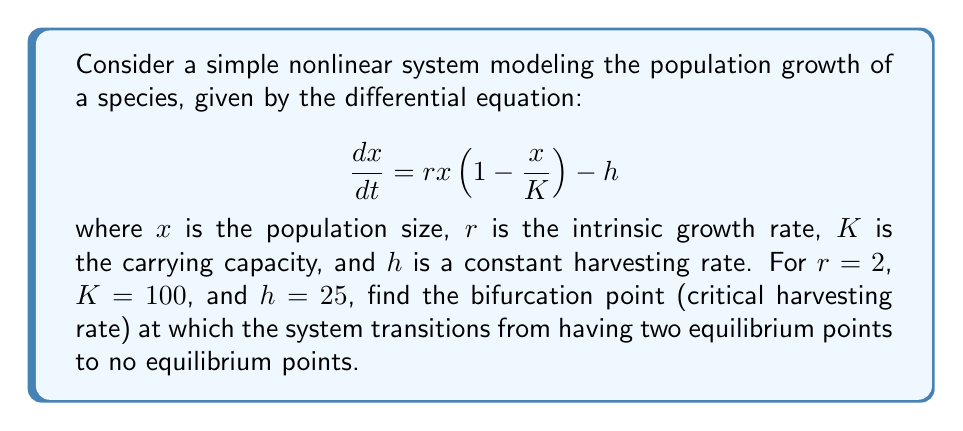Solve this math problem. Let's approach this step-by-step:

1) First, we need to find the equilibrium points. These occur when $\frac{dx}{dt} = 0$:

   $$0 = rx(1-\frac{x}{K}) - h$$

2) Substituting the given values and rearranging:

   $$0 = 2x(1-\frac{x}{100}) - 25$$
   $$0 = 2x - \frac{2x^2}{100} - 25$$
   $$0 = 2x - 0.02x^2 - 25$$

3) Multiplying everything by 50 to eliminate fractions:

   $$0 = 100x - x^2 - 1250$$

4) This is a quadratic equation. The system will have two equilibrium points when this equation has two real roots, one equilibrium point when it has one real root (at the bifurcation point), and no equilibrium points when it has no real roots.

5) For a quadratic equation $ax^2 + bx + c = 0$, the discriminant is given by $b^2 - 4ac$. At the bifurcation point, the discriminant equals zero.

6) In our case, $a=-1$, $b=100$, and $c=-1250$. The discriminant is:

   $$100^2 - 4(-1)(-1250) = 10000 - 5000 = 5000$$

7) This is positive, indicating two equilibrium points. We need to find the value of $h$ that makes the discriminant zero.

8) Let's rewrite our original equation with $h$ as a variable:

   $$0 = 2x - 0.02x^2 - h$$
   $$0 = 100x - x^2 - 50h$$

9) Now, setting the discriminant to zero:

   $$100^2 - 4(1)(50h) = 0$$
   $$10000 - 200h = 0$$
   $$200h = 10000$$
   $$h = 50$$

Therefore, the bifurcation point occurs when the harvesting rate $h = 50$.
Answer: $h = 50$ 